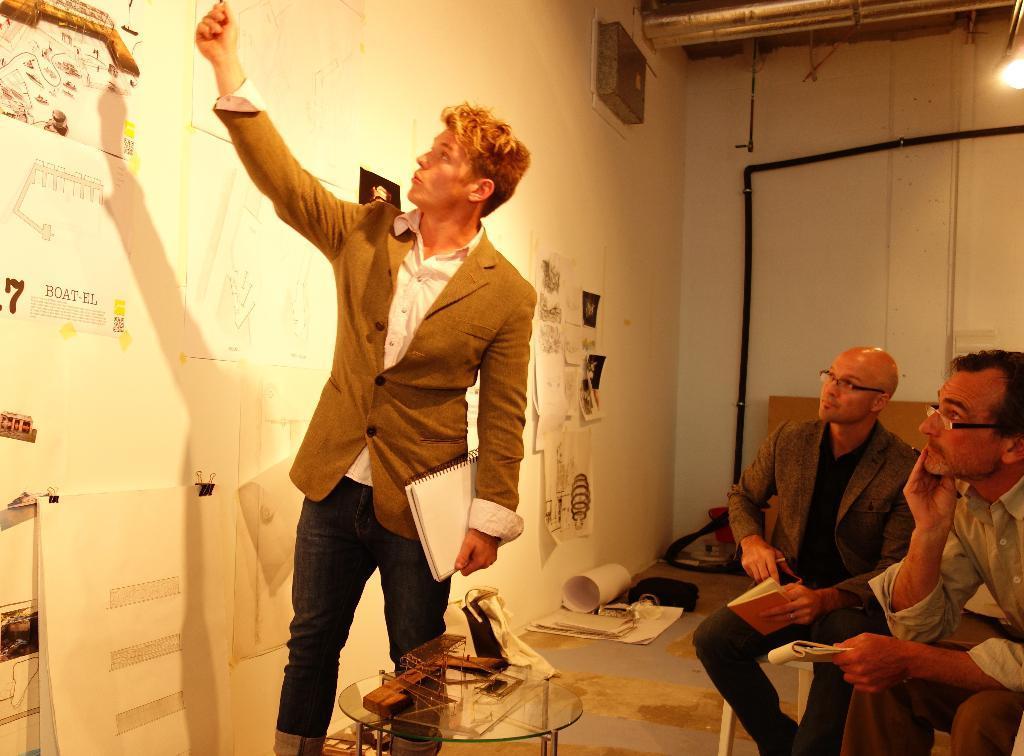Describe this image in one or two sentences. In this picture I can observe three men. Two of them are sitting on the chair and one of them is standing in the middle of the picture. On the left side I can observe some charts on the wall. In the background I can observe wall. 